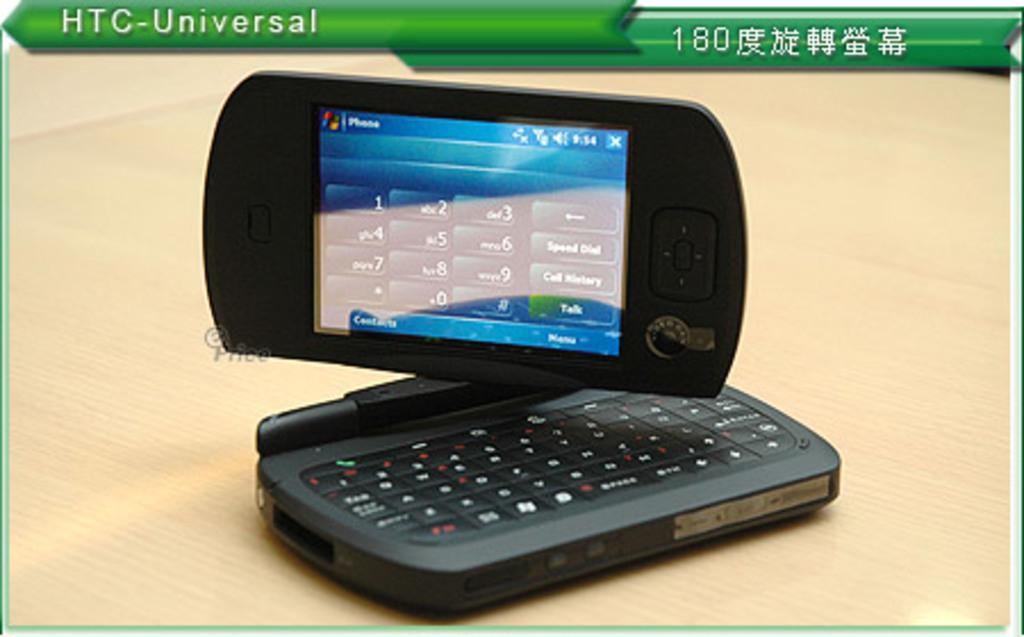Provide a one-sentence caption for the provided image. An advertisement displaying a HTC-Universal phone keypad on the screen. 